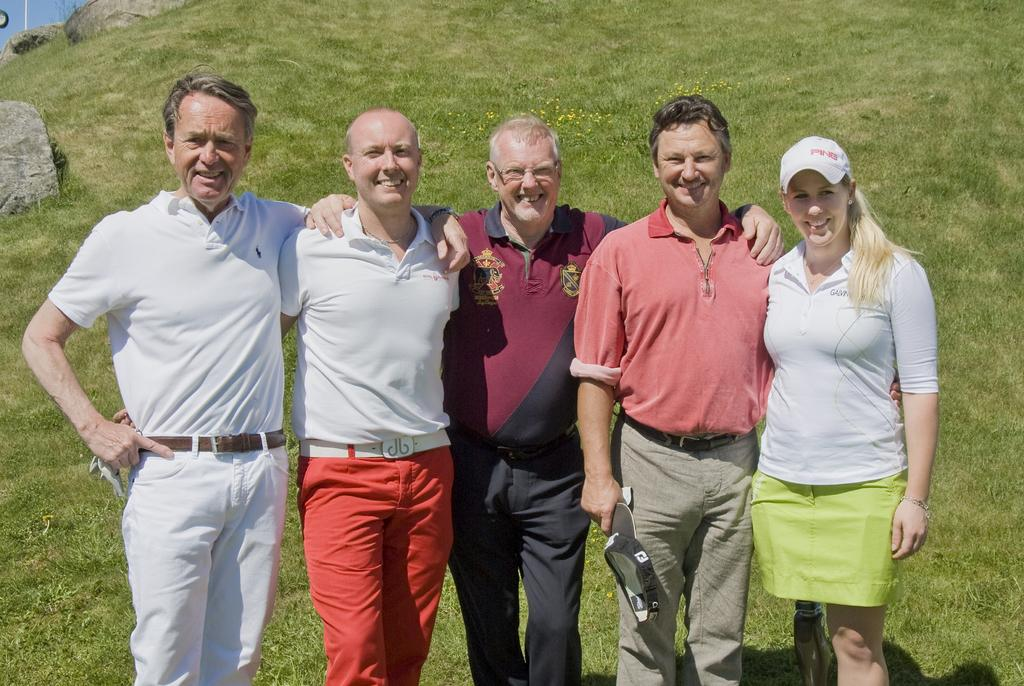How many people are in the image? There are four men and a woman in the image, making a total of five people. What are the people doing in the image? The people are standing in the image. What is the general mood of the people in the image? The people are smiling, which suggests a positive or happy mood. What is the woman wearing on her head? The woman is wearing a cap in the image. What type of surface can be seen in the image? There is grass and stones visible in the image. What is the name of the father in the image? There is no information about the relationship between the people in the image, so we cannot determine who the father is. What is the zinc content in the stones in the image? There is no information about the chemical composition of the stones in the image, so we cannot determine the zinc content. 